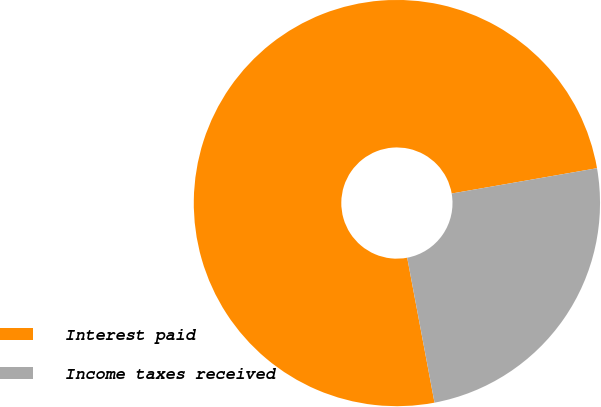Convert chart to OTSL. <chart><loc_0><loc_0><loc_500><loc_500><pie_chart><fcel>Interest paid<fcel>Income taxes received<nl><fcel>75.22%<fcel>24.78%<nl></chart> 